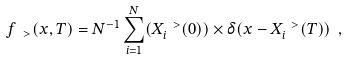Convert formula to latex. <formula><loc_0><loc_0><loc_500><loc_500>f _ { \, \ > } ( x , T ) = N ^ { - 1 } \sum _ { i = 1 } ^ { N } ( X _ { i } ^ { \ > } ( 0 ) ) \times \delta ( x - X _ { i } ^ { \ > } ( T ) ) \ ,</formula> 